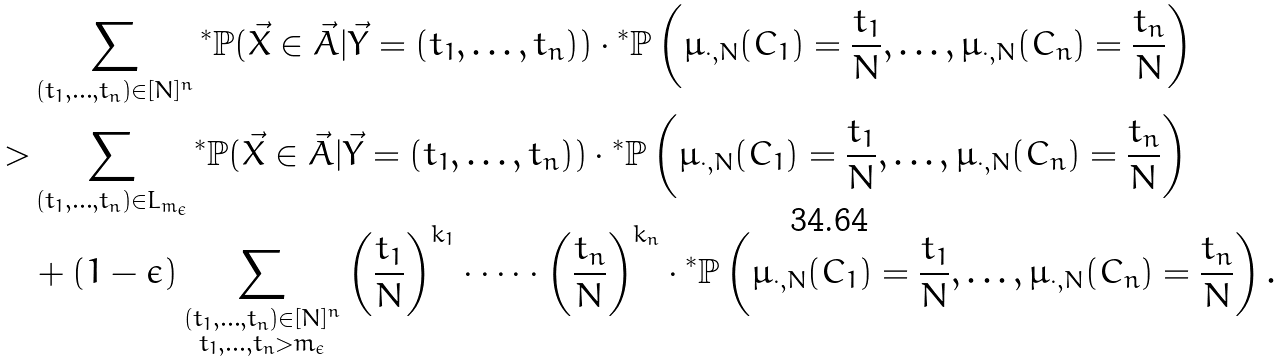<formula> <loc_0><loc_0><loc_500><loc_500>& \sum _ { \substack { ( t _ { 1 } , \dots , t _ { n } ) \in [ N ] ^ { n } } } { ^ { * } } \mathbb { P } ( \vec { X } \in \vec { A } | \vec { Y } = ( t _ { 1 } , \dots , t _ { n } ) ) \cdot { ^ { * } } \mathbb { P } \left ( \mu _ { \cdot , N } ( C _ { 1 } ) = \frac { t _ { 1 } } { N } , \dots , \mu _ { \cdot , N } ( C _ { n } ) = \frac { t _ { n } } { N } \right ) \\ > & \sum _ { \substack { ( t _ { 1 } , \dots , t _ { n } ) \in L _ { m _ { \epsilon } } } } { ^ { * } } \mathbb { P } ( \vec { X } \in \vec { A } | \vec { Y } = ( t _ { 1 } , \dots , t _ { n } ) ) \cdot { ^ { * } } \mathbb { P } \left ( \mu _ { \cdot , N } ( C _ { 1 } ) = \frac { t _ { 1 } } { N } , \dots , \mu _ { \cdot , N } ( C _ { n } ) = \frac { t _ { n } } { N } \right ) \\ & + ( 1 - \epsilon ) \sum _ { \substack { ( t _ { 1 } , \dots , t _ { n } ) \in [ N ] ^ { n } \\ t _ { 1 } , \dots , t _ { n } > m _ { \epsilon } } } \left ( \frac { t _ { 1 } } { N } \right ) ^ { k _ { 1 } } \cdot \dots \cdot \left ( \frac { t _ { n } } { N } \right ) ^ { k _ { n } } \cdot { ^ { * } } \mathbb { P } \left ( \mu _ { \cdot , N } ( C _ { 1 } ) = \frac { t _ { 1 } } { N } , \dots , \mu _ { \cdot , N } ( C _ { n } ) = \frac { t _ { n } } { N } \right ) .</formula> 